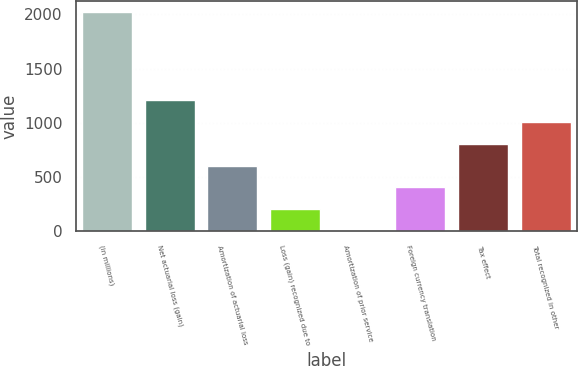Convert chart. <chart><loc_0><loc_0><loc_500><loc_500><bar_chart><fcel>(in millions)<fcel>Net actuarial loss (gain)<fcel>Amortization of actuarial loss<fcel>Loss (gain) recognized due to<fcel>Amortization of prior service<fcel>Foreign currency translation<fcel>Tax effect<fcel>Total recognized in other<nl><fcel>2019<fcel>1212.08<fcel>606.89<fcel>203.43<fcel>1.7<fcel>405.16<fcel>808.62<fcel>1010.35<nl></chart> 